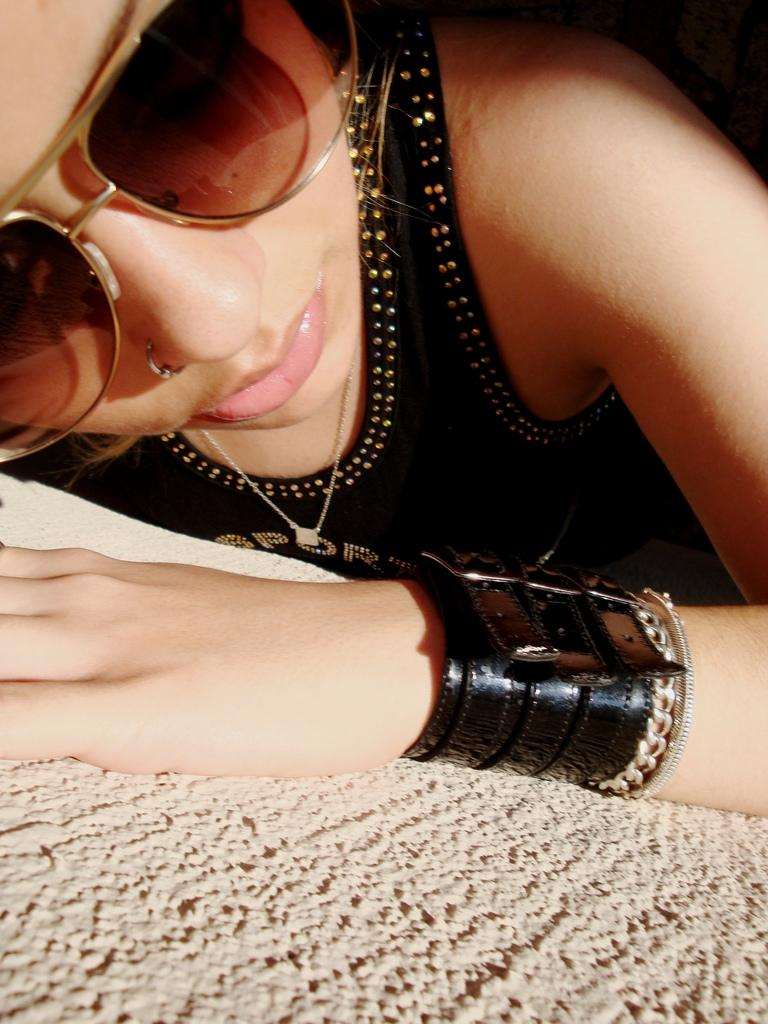Who is the main subject in the foreground of the image? There is a woman in the foreground of the image. What is the woman wearing in the image? The woman is wearing a black dress and spectacles. What is the woman's position in the image? The woman is lying on a surface. What type of bell can be heard ringing in the background of the image? There is no bell present or audible in the image, as it is a still photograph. 